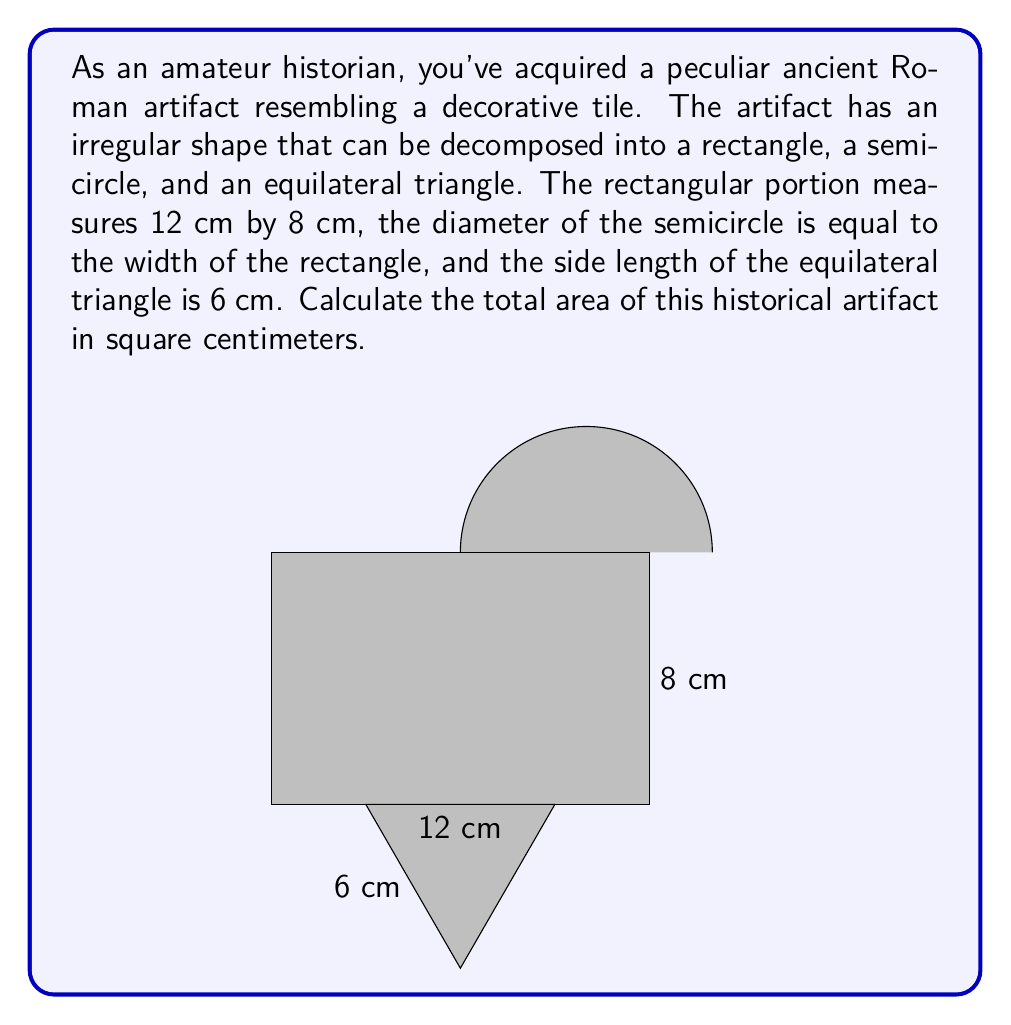Give your solution to this math problem. To find the total area of the artifact, we need to calculate the areas of its components and sum them up:

1. Area of the rectangle:
   $A_r = l \times w = 12 \text{ cm} \times 8 \text{ cm} = 96 \text{ cm}^2$

2. Area of the semicircle:
   The diameter is 8 cm (width of the rectangle), so the radius is 4 cm.
   $A_s = \frac{1}{2} \times \pi r^2 = \frac{1}{2} \times \pi \times (4 \text{ cm})^2 = 8\pi \text{ cm}^2$

3. Area of the equilateral triangle:
   For an equilateral triangle with side length $s$, the area is given by $A_t = \frac{\sqrt{3}}{4}s^2$
   $A_t = \frac{\sqrt{3}}{4} \times (6 \text{ cm})^2 = 9\sqrt{3} \text{ cm}^2$

Total area:
$$A_{\text{total}} = A_r + A_s + A_t = 96 + 8\pi + 9\sqrt{3} \text{ cm}^2$$

To simplify, we can leave $\pi$ and $\sqrt{3}$ in their symbolic forms:
$$A_{\text{total}} = (96 + 8\pi + 9\sqrt{3}) \text{ cm}^2$$
Answer: $(96 + 8\pi + 9\sqrt{3}) \text{ cm}^2$ 